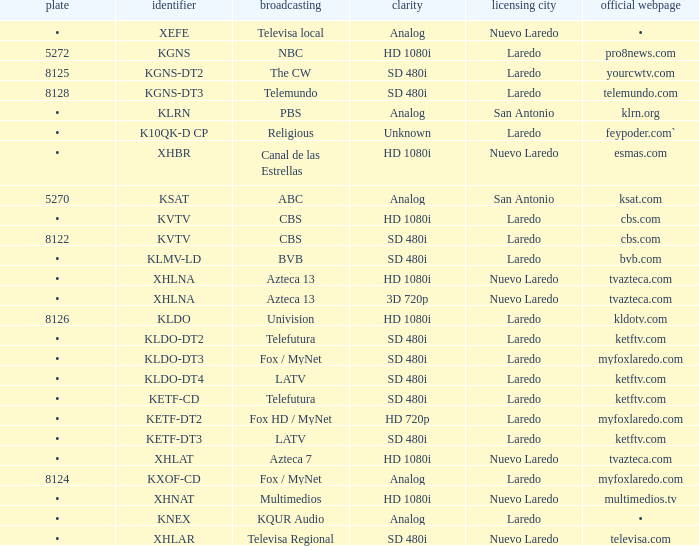What is the cuisine for a 480i sd resolution and bvb network connection? •. 